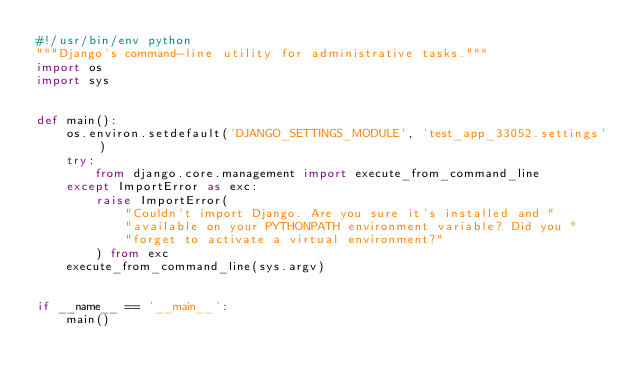<code> <loc_0><loc_0><loc_500><loc_500><_Python_>#!/usr/bin/env python
"""Django's command-line utility for administrative tasks."""
import os
import sys


def main():
    os.environ.setdefault('DJANGO_SETTINGS_MODULE', 'test_app_33052.settings')
    try:
        from django.core.management import execute_from_command_line
    except ImportError as exc:
        raise ImportError(
            "Couldn't import Django. Are you sure it's installed and "
            "available on your PYTHONPATH environment variable? Did you "
            "forget to activate a virtual environment?"
        ) from exc
    execute_from_command_line(sys.argv)


if __name__ == '__main__':
    main()
</code> 